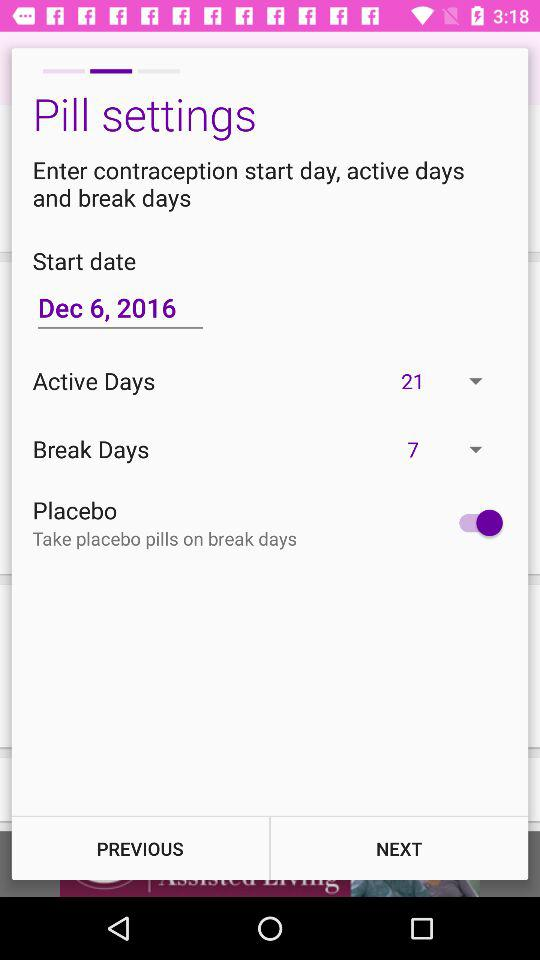How many days are there in the active pill cycle?
Answer the question using a single word or phrase. 21 